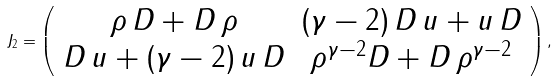<formula> <loc_0><loc_0><loc_500><loc_500>J _ { 2 } = \left ( \begin{array} { c c } \rho \, D + D \, \rho & ( \gamma - 2 ) \, D \, u + u \, D \\ D \, u + ( \gamma - 2 ) \, u \, D & \rho ^ { \gamma - 2 } D + D \, \rho ^ { \gamma - 2 } \end{array} \right ) ,</formula> 